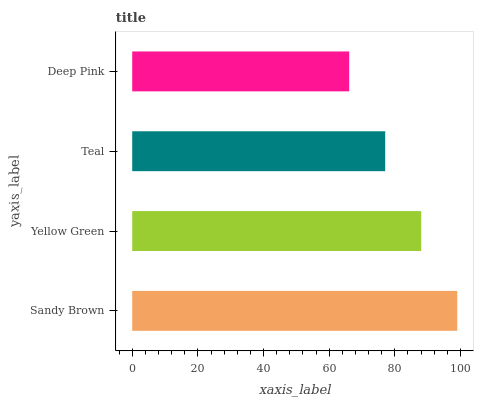Is Deep Pink the minimum?
Answer yes or no. Yes. Is Sandy Brown the maximum?
Answer yes or no. Yes. Is Yellow Green the minimum?
Answer yes or no. No. Is Yellow Green the maximum?
Answer yes or no. No. Is Sandy Brown greater than Yellow Green?
Answer yes or no. Yes. Is Yellow Green less than Sandy Brown?
Answer yes or no. Yes. Is Yellow Green greater than Sandy Brown?
Answer yes or no. No. Is Sandy Brown less than Yellow Green?
Answer yes or no. No. Is Yellow Green the high median?
Answer yes or no. Yes. Is Teal the low median?
Answer yes or no. Yes. Is Teal the high median?
Answer yes or no. No. Is Yellow Green the low median?
Answer yes or no. No. 